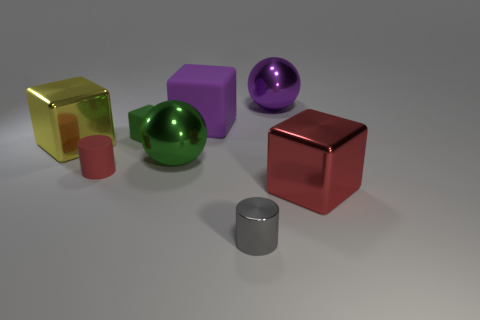Subtract all big yellow blocks. How many blocks are left? 3 Add 2 large purple things. How many objects exist? 10 Subtract 1 spheres. How many spheres are left? 1 Subtract all gray cylinders. How many cylinders are left? 1 Subtract all cylinders. How many objects are left? 6 Subtract all blue blocks. How many yellow cylinders are left? 0 Add 7 tiny red things. How many tiny red things exist? 8 Subtract 0 cyan blocks. How many objects are left? 8 Subtract all yellow cylinders. Subtract all gray spheres. How many cylinders are left? 2 Subtract all large red objects. Subtract all purple cubes. How many objects are left? 6 